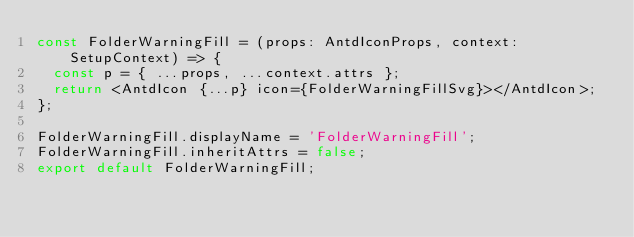<code> <loc_0><loc_0><loc_500><loc_500><_TypeScript_>const FolderWarningFill = (props: AntdIconProps, context: SetupContext) => {
  const p = { ...props, ...context.attrs };
  return <AntdIcon {...p} icon={FolderWarningFillSvg}></AntdIcon>;
};

FolderWarningFill.displayName = 'FolderWarningFill';
FolderWarningFill.inheritAttrs = false;
export default FolderWarningFill;</code> 